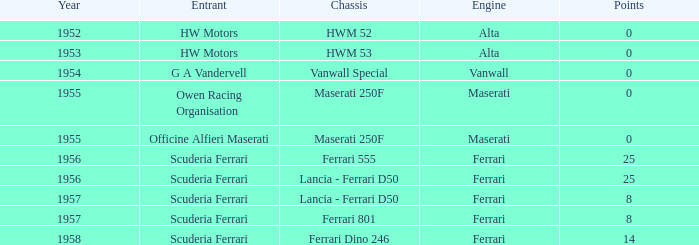What is the most points when Maserati made the engine, and a Entrant of owen racing organisation? 0.0. 